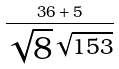<formula> <loc_0><loc_0><loc_500><loc_500>\frac { 3 6 + 5 } { \sqrt { 8 } ^ { \sqrt { 1 5 3 } } }</formula> 